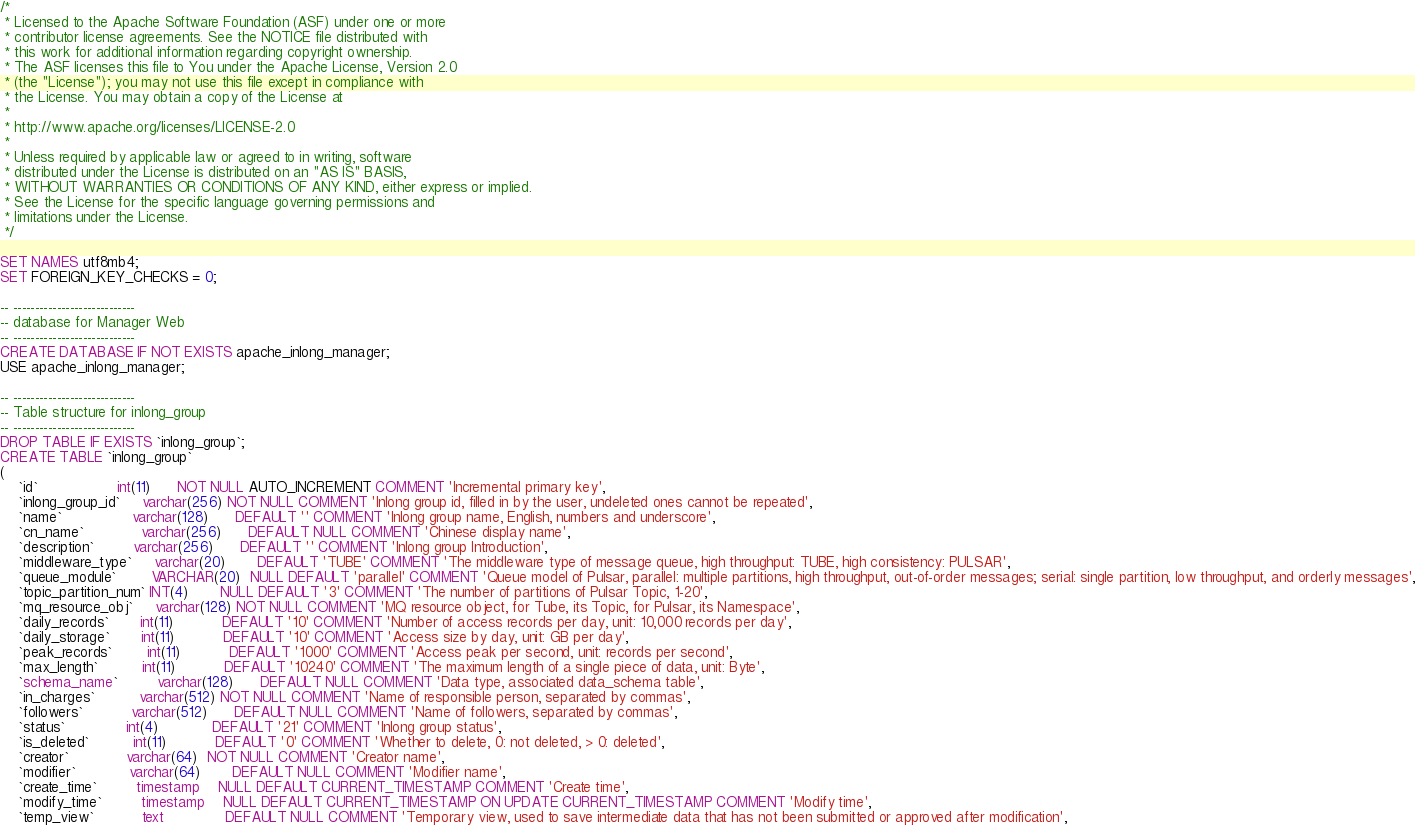<code> <loc_0><loc_0><loc_500><loc_500><_SQL_>/*
 * Licensed to the Apache Software Foundation (ASF) under one or more
 * contributor license agreements. See the NOTICE file distributed with
 * this work for additional information regarding copyright ownership.
 * The ASF licenses this file to You under the Apache License, Version 2.0
 * (the "License"); you may not use this file except in compliance with
 * the License. You may obtain a copy of the License at
 *
 * http://www.apache.org/licenses/LICENSE-2.0
 *
 * Unless required by applicable law or agreed to in writing, software
 * distributed under the License is distributed on an "AS IS" BASIS,
 * WITHOUT WARRANTIES OR CONDITIONS OF ANY KIND, either express or implied.
 * See the License for the specific language governing permissions and
 * limitations under the License.
 */

SET NAMES utf8mb4;
SET FOREIGN_KEY_CHECKS = 0;

-- ----------------------------
-- database for Manager Web
-- ----------------------------
CREATE DATABASE IF NOT EXISTS apache_inlong_manager;
USE apache_inlong_manager;

-- ----------------------------
-- Table structure for inlong_group
-- ----------------------------
DROP TABLE IF EXISTS `inlong_group`;
CREATE TABLE `inlong_group`
(
    `id`                  int(11)      NOT NULL AUTO_INCREMENT COMMENT 'Incremental primary key',
    `inlong_group_id`     varchar(256) NOT NULL COMMENT 'Inlong group id, filled in by the user, undeleted ones cannot be repeated',
    `name`                varchar(128)      DEFAULT '' COMMENT 'Inlong group name, English, numbers and underscore',
    `cn_name`             varchar(256)      DEFAULT NULL COMMENT 'Chinese display name',
    `description`         varchar(256)      DEFAULT '' COMMENT 'Inlong group Introduction',
    `middleware_type`     varchar(20)       DEFAULT 'TUBE' COMMENT 'The middleware type of message queue, high throughput: TUBE, high consistency: PULSAR',
    `queue_module`        VARCHAR(20)  NULL DEFAULT 'parallel' COMMENT 'Queue model of Pulsar, parallel: multiple partitions, high throughput, out-of-order messages; serial: single partition, low throughput, and orderly messages',
    `topic_partition_num` INT(4)       NULL DEFAULT '3' COMMENT 'The number of partitions of Pulsar Topic, 1-20',
    `mq_resource_obj`     varchar(128) NOT NULL COMMENT 'MQ resource object, for Tube, its Topic, for Pulsar, its Namespace',
    `daily_records`       int(11)           DEFAULT '10' COMMENT 'Number of access records per day, unit: 10,000 records per day',
    `daily_storage`       int(11)           DEFAULT '10' COMMENT 'Access size by day, unit: GB per day',
    `peak_records`        int(11)           DEFAULT '1000' COMMENT 'Access peak per second, unit: records per second',
    `max_length`          int(11)           DEFAULT '10240' COMMENT 'The maximum length of a single piece of data, unit: Byte',
    `schema_name`         varchar(128)      DEFAULT NULL COMMENT 'Data type, associated data_schema table',
    `in_charges`          varchar(512) NOT NULL COMMENT 'Name of responsible person, separated by commas',
    `followers`           varchar(512)      DEFAULT NULL COMMENT 'Name of followers, separated by commas',
    `status`              int(4)            DEFAULT '21' COMMENT 'Inlong group status',
    `is_deleted`          int(11)           DEFAULT '0' COMMENT 'Whether to delete, 0: not deleted, > 0: deleted',
    `creator`             varchar(64)  NOT NULL COMMENT 'Creator name',
    `modifier`            varchar(64)       DEFAULT NULL COMMENT 'Modifier name',
    `create_time`         timestamp    NULL DEFAULT CURRENT_TIMESTAMP COMMENT 'Create time',
    `modify_time`         timestamp    NULL DEFAULT CURRENT_TIMESTAMP ON UPDATE CURRENT_TIMESTAMP COMMENT 'Modify time',
    `temp_view`           text              DEFAULT NULL COMMENT 'Temporary view, used to save intermediate data that has not been submitted or approved after modification',</code> 